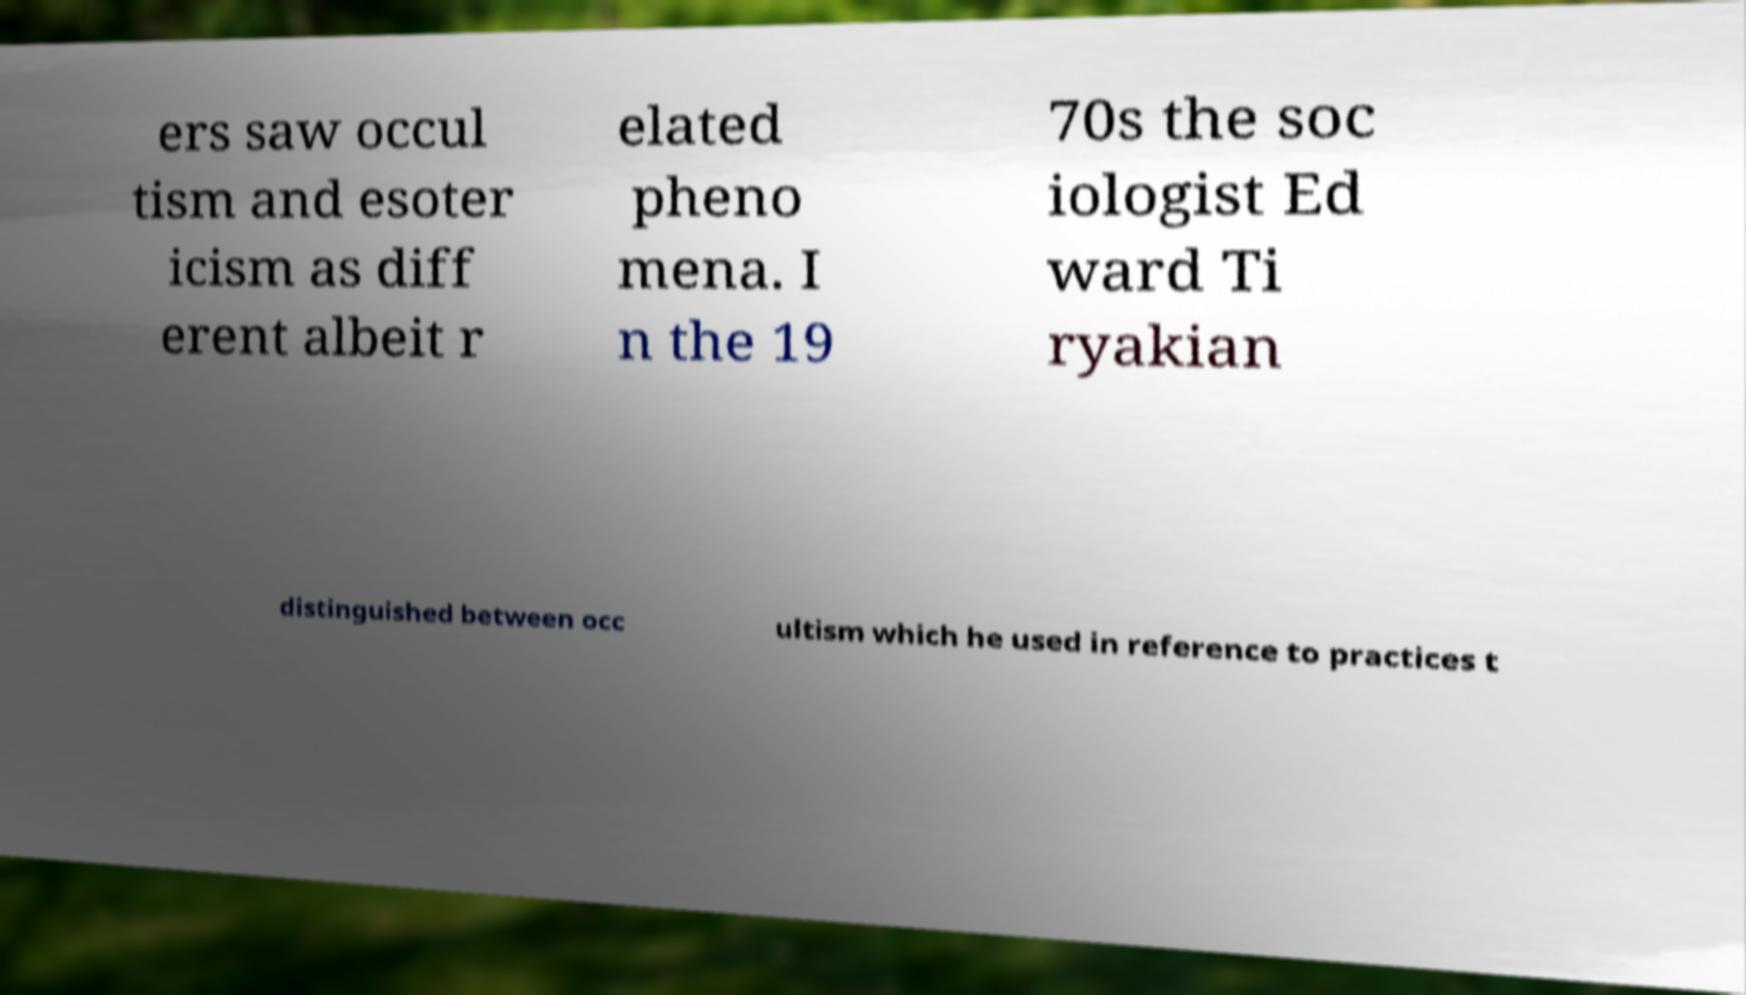What messages or text are displayed in this image? I need them in a readable, typed format. ers saw occul tism and esoter icism as diff erent albeit r elated pheno mena. I n the 19 70s the soc iologist Ed ward Ti ryakian distinguished between occ ultism which he used in reference to practices t 